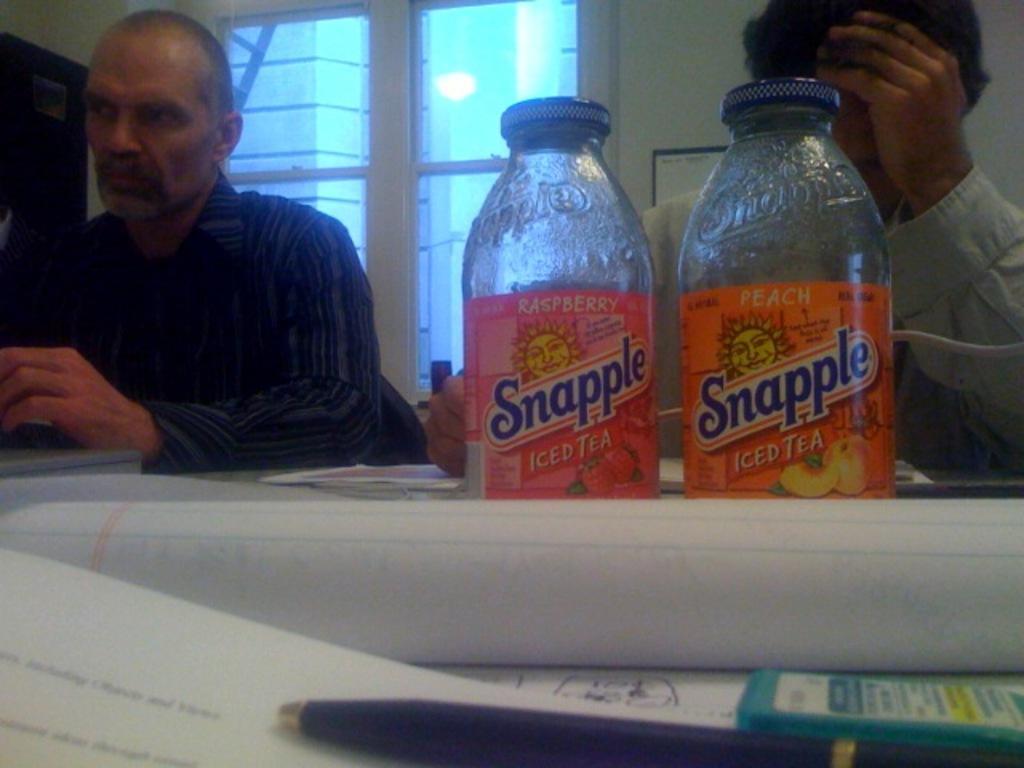Could you give a brief overview of what you see in this image? In this image, there are two persons sitting on the chair, in front of the table on which glass, bottles are kept and pen paper and soon kept. In the background there is a window of glass. And a wall visible of white in color. In the left top there is a door of brown in color visible. This image is taken inside a house. 